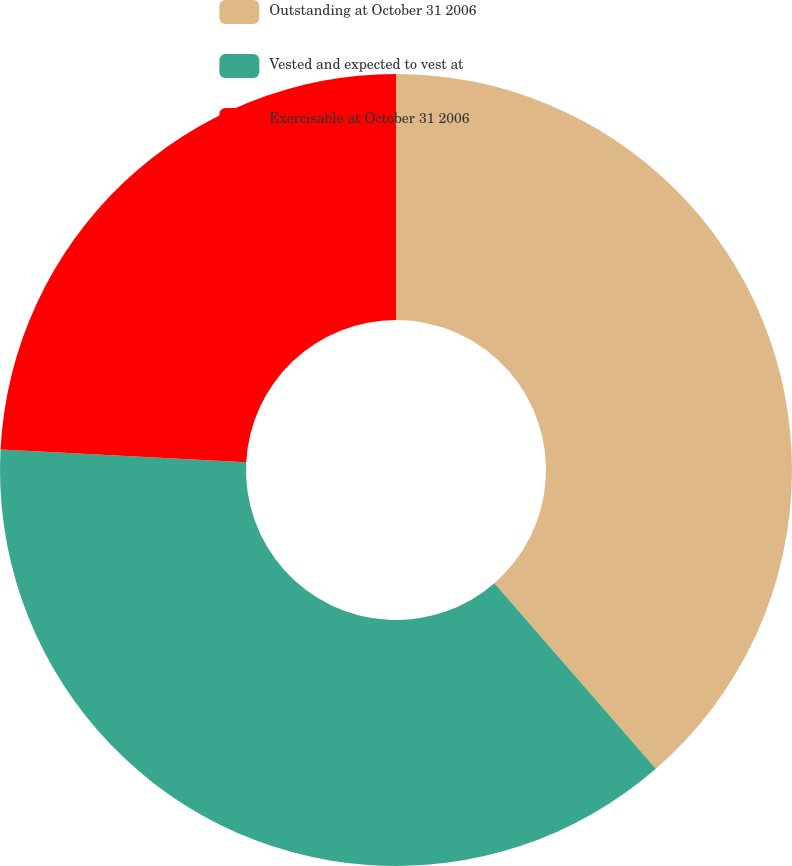Convert chart. <chart><loc_0><loc_0><loc_500><loc_500><pie_chart><fcel>Outstanding at October 31 2006<fcel>Vested and expected to vest at<fcel>Exercisable at October 31 2006<nl><fcel>38.61%<fcel>37.21%<fcel>24.18%<nl></chart> 